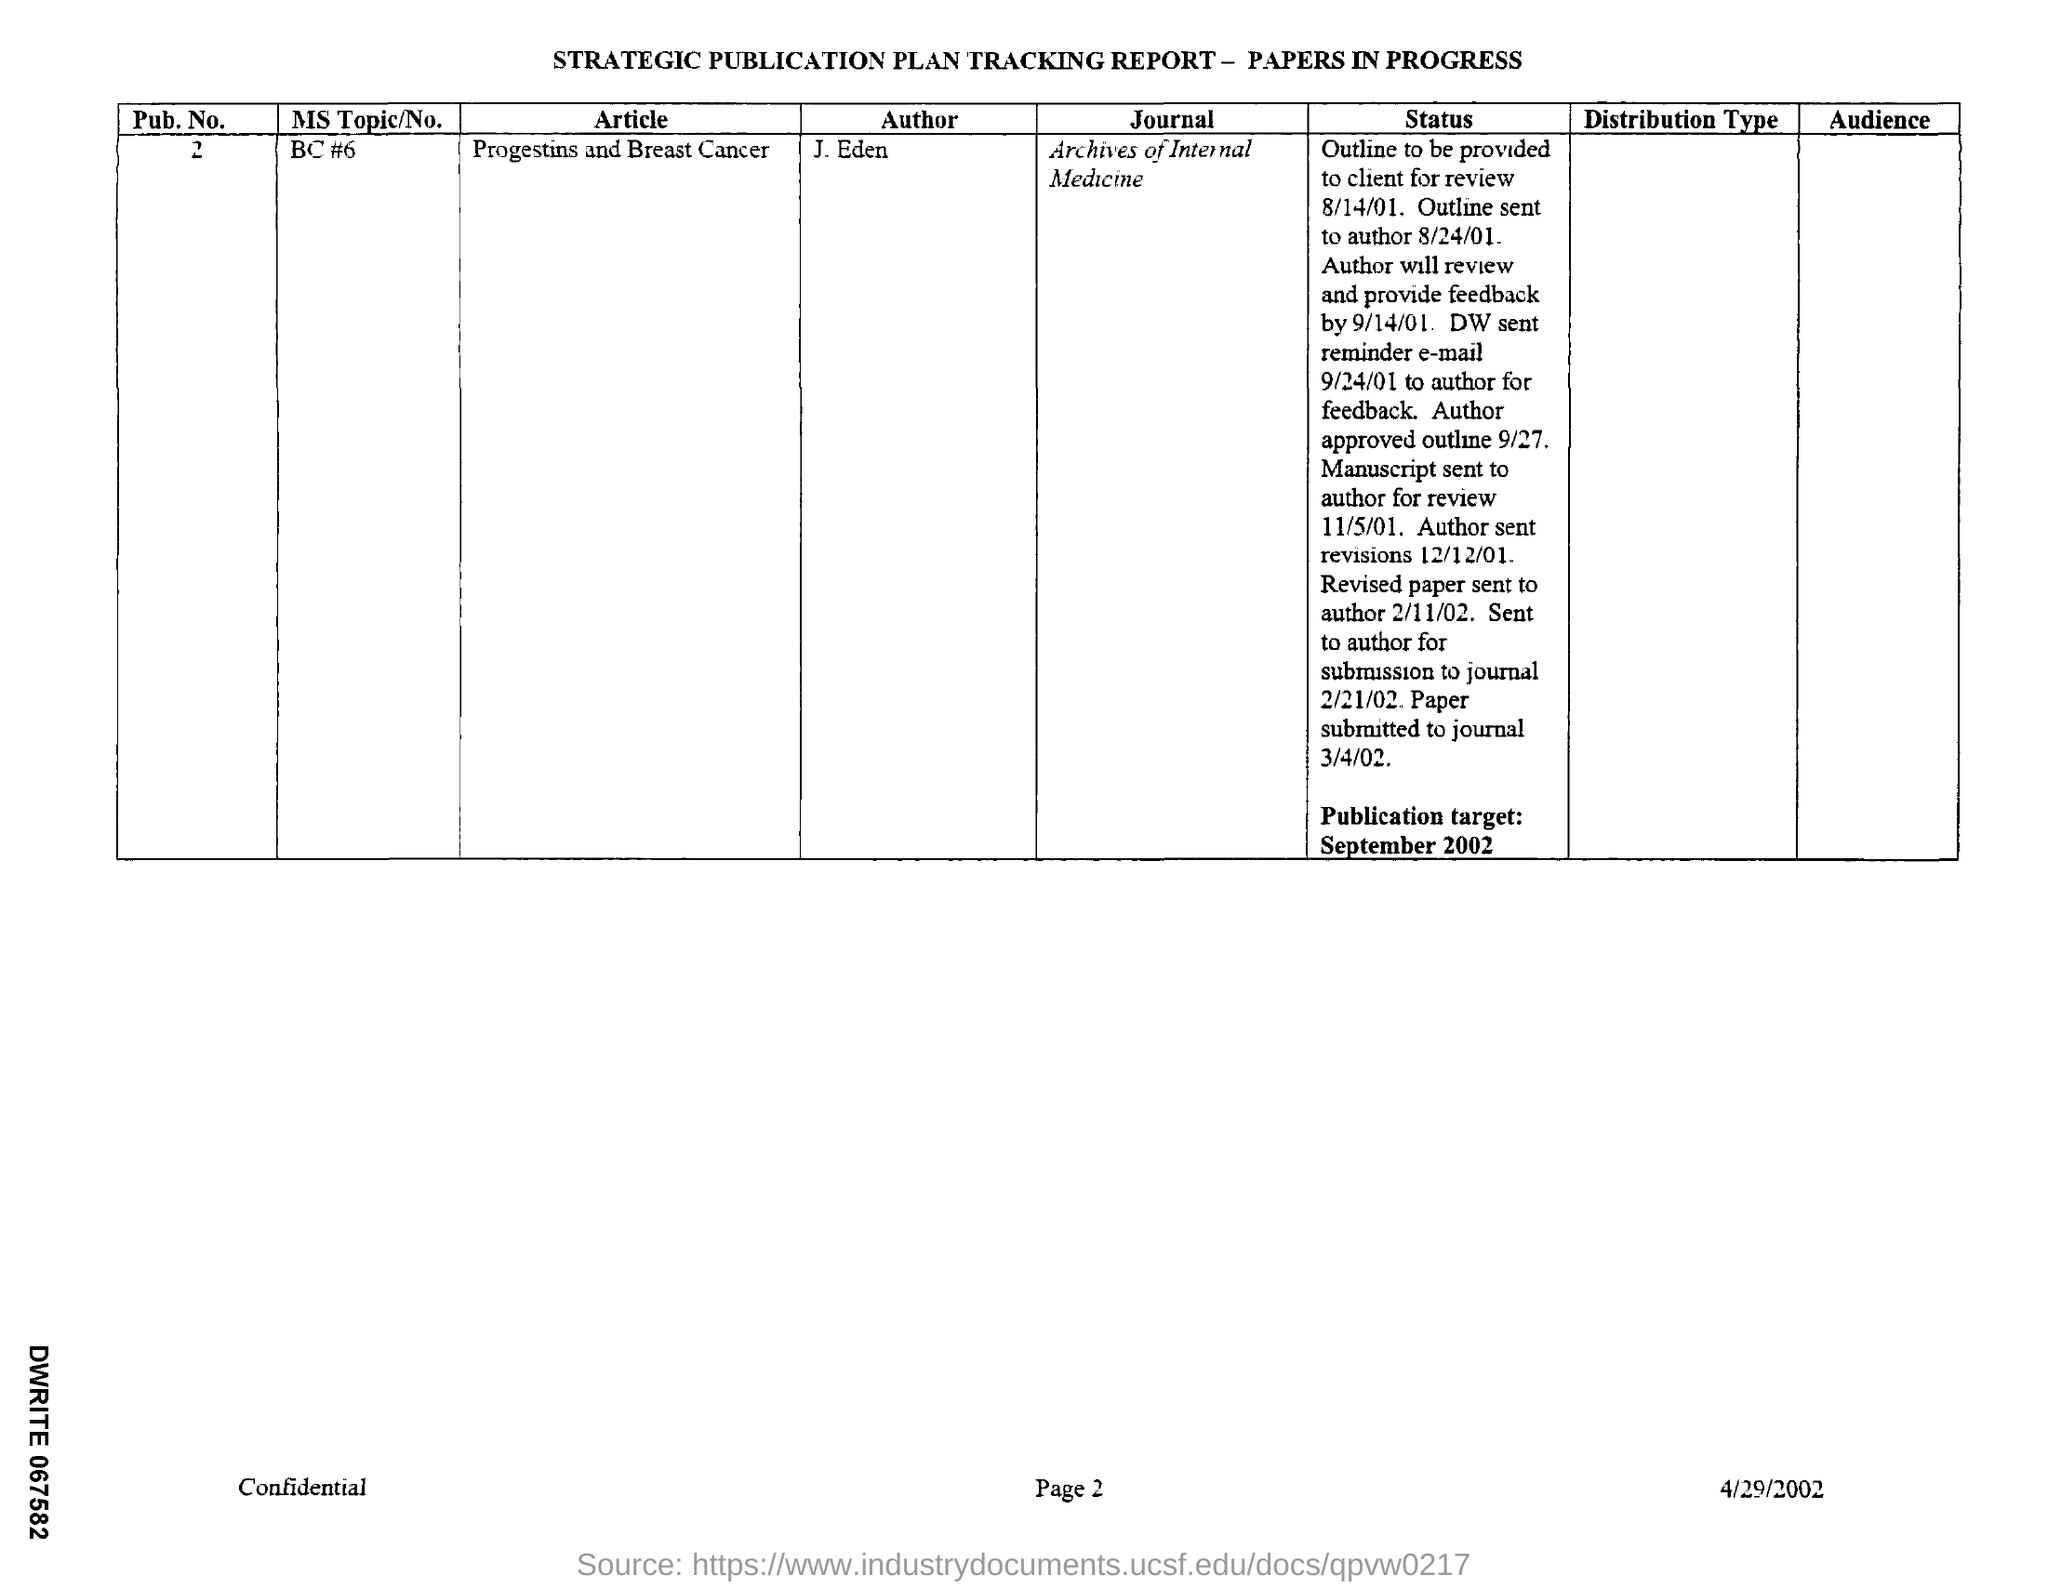What is the Pub. No.?
Your answer should be very brief. 2. What is the name of the article?
Make the answer very short. Progestins and Breast cancer. In which Journal is the paper going to published?
Offer a terse response. Archives of Internal Medicine. When is the Publication target?
Make the answer very short. September 2002. When was the Paper submitted to journal?
Provide a short and direct response. 3/4/02. 